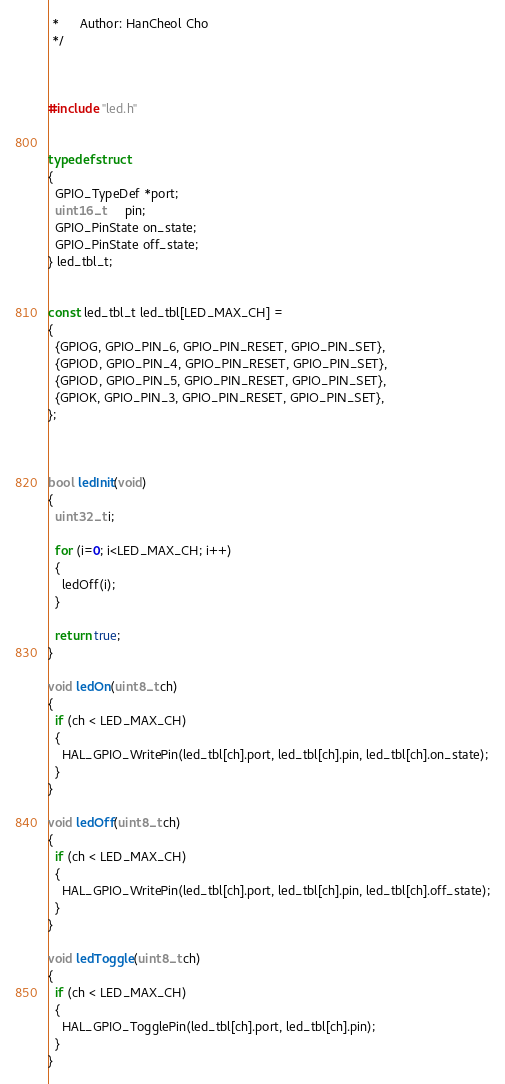Convert code to text. <code><loc_0><loc_0><loc_500><loc_500><_C_> *      Author: HanCheol Cho
 */



#include "led.h"


typedef struct
{
  GPIO_TypeDef *port;
  uint16_t      pin;
  GPIO_PinState on_state;
  GPIO_PinState off_state;
} led_tbl_t;


const led_tbl_t led_tbl[LED_MAX_CH] =
{
  {GPIOG, GPIO_PIN_6, GPIO_PIN_RESET, GPIO_PIN_SET},
  {GPIOD, GPIO_PIN_4, GPIO_PIN_RESET, GPIO_PIN_SET},
  {GPIOD, GPIO_PIN_5, GPIO_PIN_RESET, GPIO_PIN_SET},
  {GPIOK, GPIO_PIN_3, GPIO_PIN_RESET, GPIO_PIN_SET},
};



bool ledInit(void)
{
  uint32_t i;

  for (i=0; i<LED_MAX_CH; i++)
  {
    ledOff(i);
  }

  return true;
}

void ledOn(uint8_t ch)
{
  if (ch < LED_MAX_CH)
  {
    HAL_GPIO_WritePin(led_tbl[ch].port, led_tbl[ch].pin, led_tbl[ch].on_state);
  }
}

void ledOff(uint8_t ch)
{
  if (ch < LED_MAX_CH)
  {
    HAL_GPIO_WritePin(led_tbl[ch].port, led_tbl[ch].pin, led_tbl[ch].off_state);
  }
}

void ledToggle(uint8_t ch)
{
  if (ch < LED_MAX_CH)
  {
    HAL_GPIO_TogglePin(led_tbl[ch].port, led_tbl[ch].pin);
  }
}
</code> 